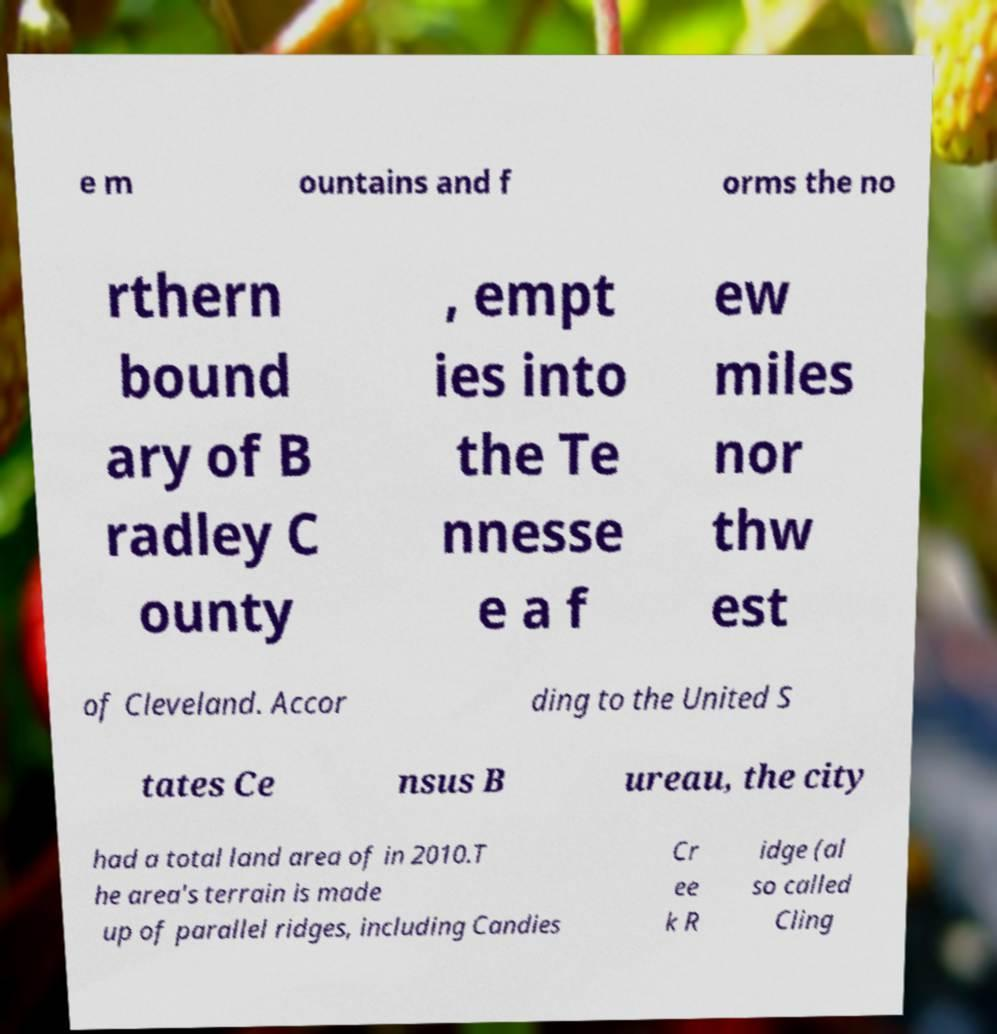What messages or text are displayed in this image? I need them in a readable, typed format. e m ountains and f orms the no rthern bound ary of B radley C ounty , empt ies into the Te nnesse e a f ew miles nor thw est of Cleveland. Accor ding to the United S tates Ce nsus B ureau, the city had a total land area of in 2010.T he area's terrain is made up of parallel ridges, including Candies Cr ee k R idge (al so called Cling 